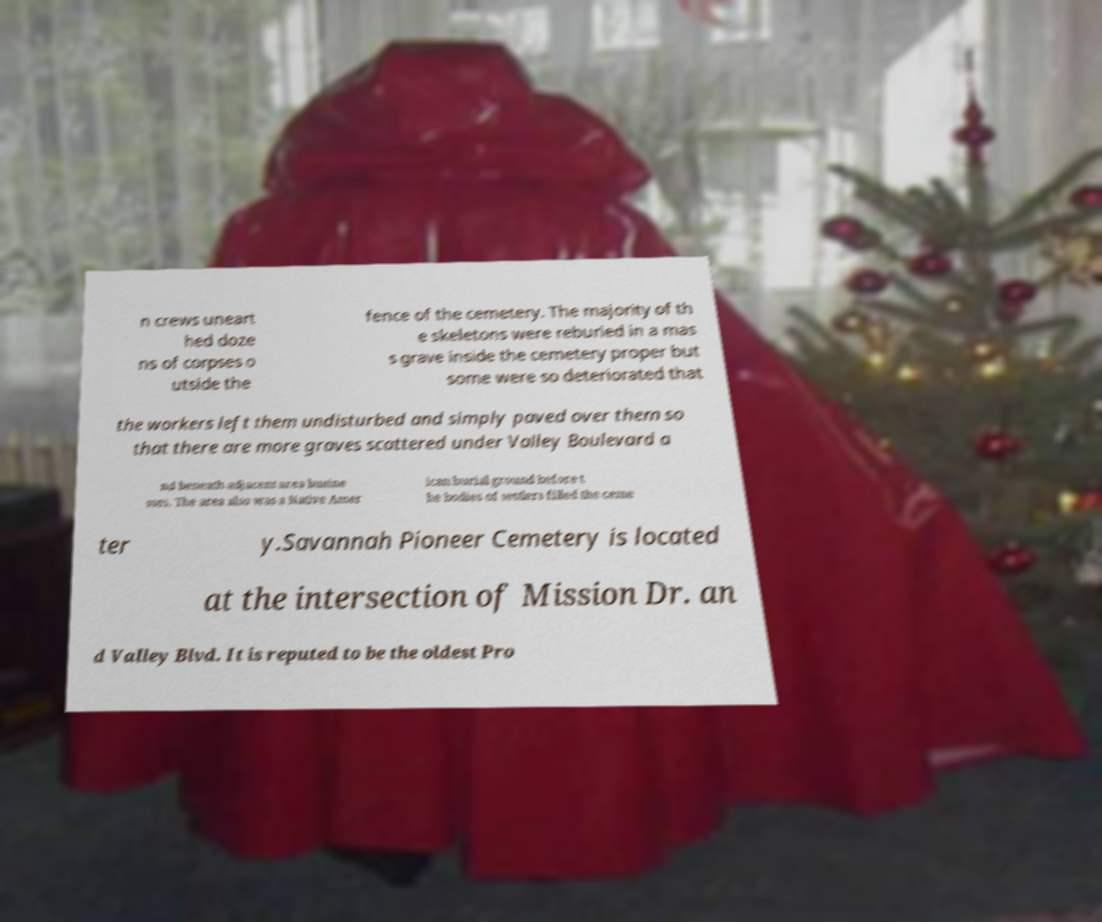There's text embedded in this image that I need extracted. Can you transcribe it verbatim? n crews uneart hed doze ns of corpses o utside the fence of the cemetery. The majority of th e skeletons were reburied in a mas s grave inside the cemetery proper but some were so deteriorated that the workers left them undisturbed and simply paved over them so that there are more graves scattered under Valley Boulevard a nd beneath adjacent area busine sses. The area also was a Native Amer ican burial ground before t he bodies of settlers filled the ceme ter y.Savannah Pioneer Cemetery is located at the intersection of Mission Dr. an d Valley Blvd. It is reputed to be the oldest Pro 